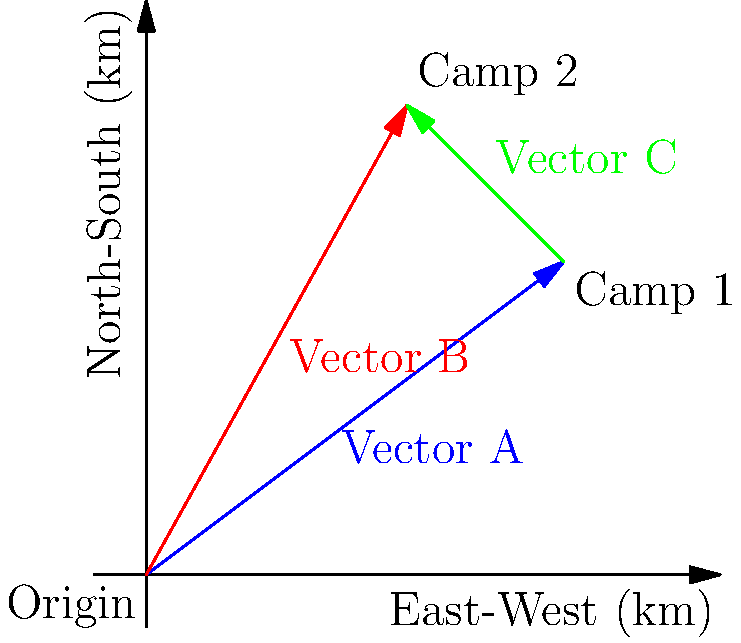As a humanitarian aid worker, you're analyzing population displacement during a refugee crisis. The diagram shows displacement vectors between refugee camps. Vector A represents the displacement from the origin to Camp 1, and Vector B represents the displacement from the origin to Camp 2. What is the magnitude of Vector C, which represents the displacement from Camp 1 to Camp 2? To find the magnitude of Vector C, we can follow these steps:

1. Identify the components of Vector A and Vector B:
   Vector A: (80, 60)
   Vector B: (50, 90)

2. Calculate Vector C by subtracting Vector A from Vector B:
   C = B - A
   C = (50, 90) - (80, 60)
   C = (-30, 30)

3. Use the Pythagorean theorem to calculate the magnitude of Vector C:
   $\text{Magnitude} = \sqrt{x^2 + y^2}$
   
   $$\begin{align}
   \text{Magnitude} &= \sqrt{(-30)^2 + (30)^2} \\
   &= \sqrt{900 + 900} \\
   &= \sqrt{1800} \\
   &\approx 42.43 \text{ km}
   \end{align}$$

Therefore, the magnitude of Vector C is approximately 42.43 km.
Answer: 42.43 km 